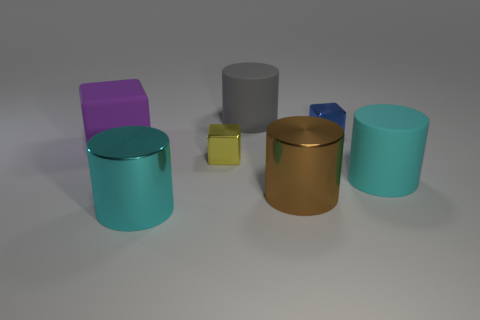What could be the purpose of this arrangement of objects? This arrangement of objects could be an artist's 3D rendering to study the effects of lighting, shadows, and reflections on different colored and sized objects. 